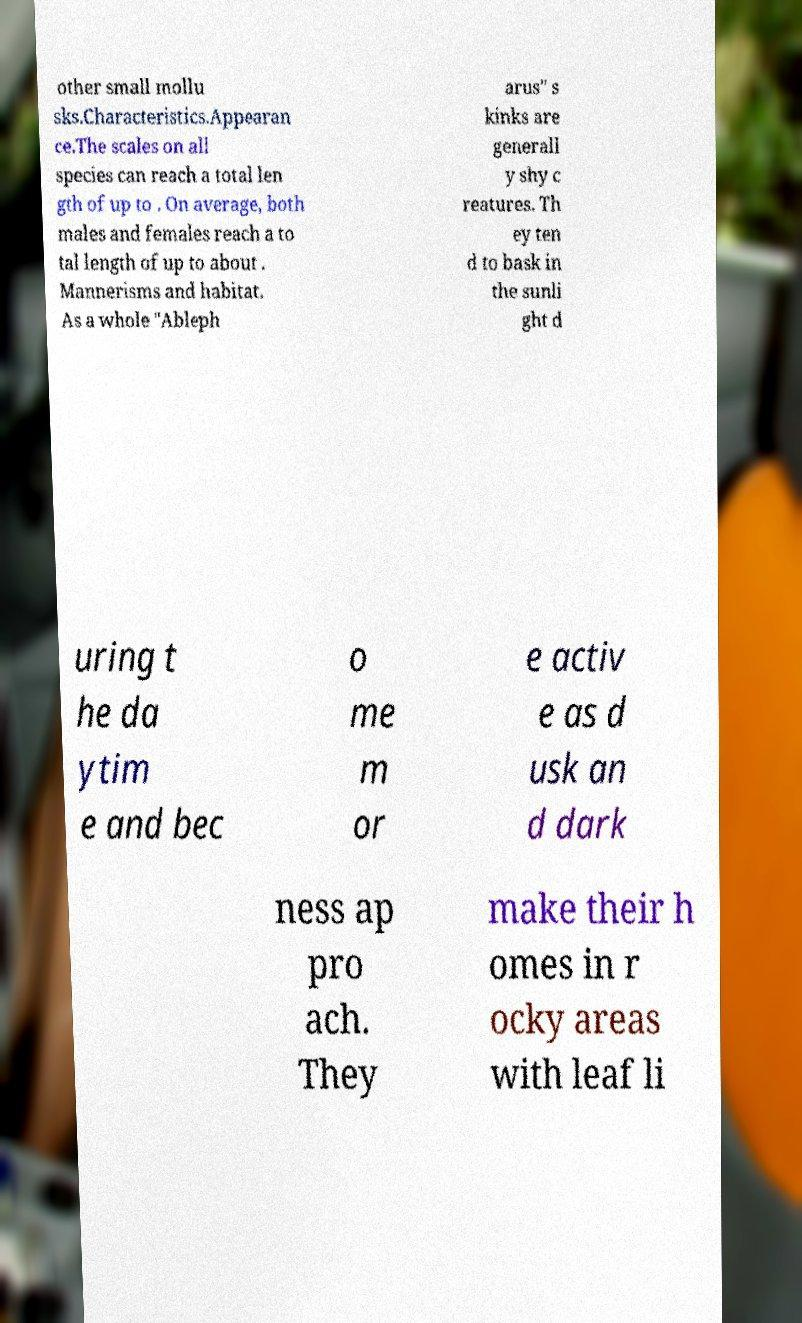Can you read and provide the text displayed in the image?This photo seems to have some interesting text. Can you extract and type it out for me? other small mollu sks.Characteristics.Appearan ce.The scales on all species can reach a total len gth of up to . On average, both males and females reach a to tal length of up to about . Mannerisms and habitat. As a whole "Ableph arus" s kinks are generall y shy c reatures. Th ey ten d to bask in the sunli ght d uring t he da ytim e and bec o me m or e activ e as d usk an d dark ness ap pro ach. They make their h omes in r ocky areas with leaf li 